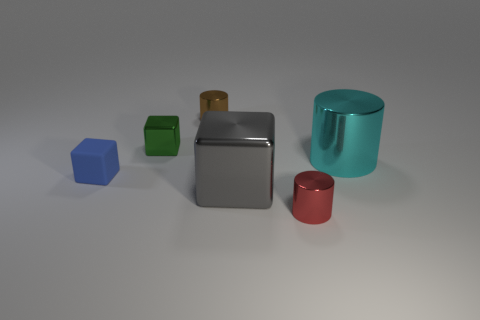Add 1 big gray things. How many objects exist? 7 Subtract all big metal cubes. How many cubes are left? 2 Subtract all blue cubes. How many cubes are left? 2 Subtract 1 cubes. How many cubes are left? 2 Subtract all gray spheres. How many purple cubes are left? 0 Subtract all metallic cubes. Subtract all small shiny cylinders. How many objects are left? 2 Add 3 brown metal cylinders. How many brown metal cylinders are left? 4 Add 1 green things. How many green things exist? 2 Subtract 0 gray balls. How many objects are left? 6 Subtract all cyan blocks. Subtract all purple balls. How many blocks are left? 3 